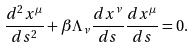Convert formula to latex. <formula><loc_0><loc_0><loc_500><loc_500>\frac { d ^ { 2 } x ^ { \mu } } { d s ^ { 2 } } + \beta \Lambda _ { \nu } \frac { d x ^ { \nu } } { d s } \frac { d x ^ { \mu } } { d s } = 0 .</formula> 